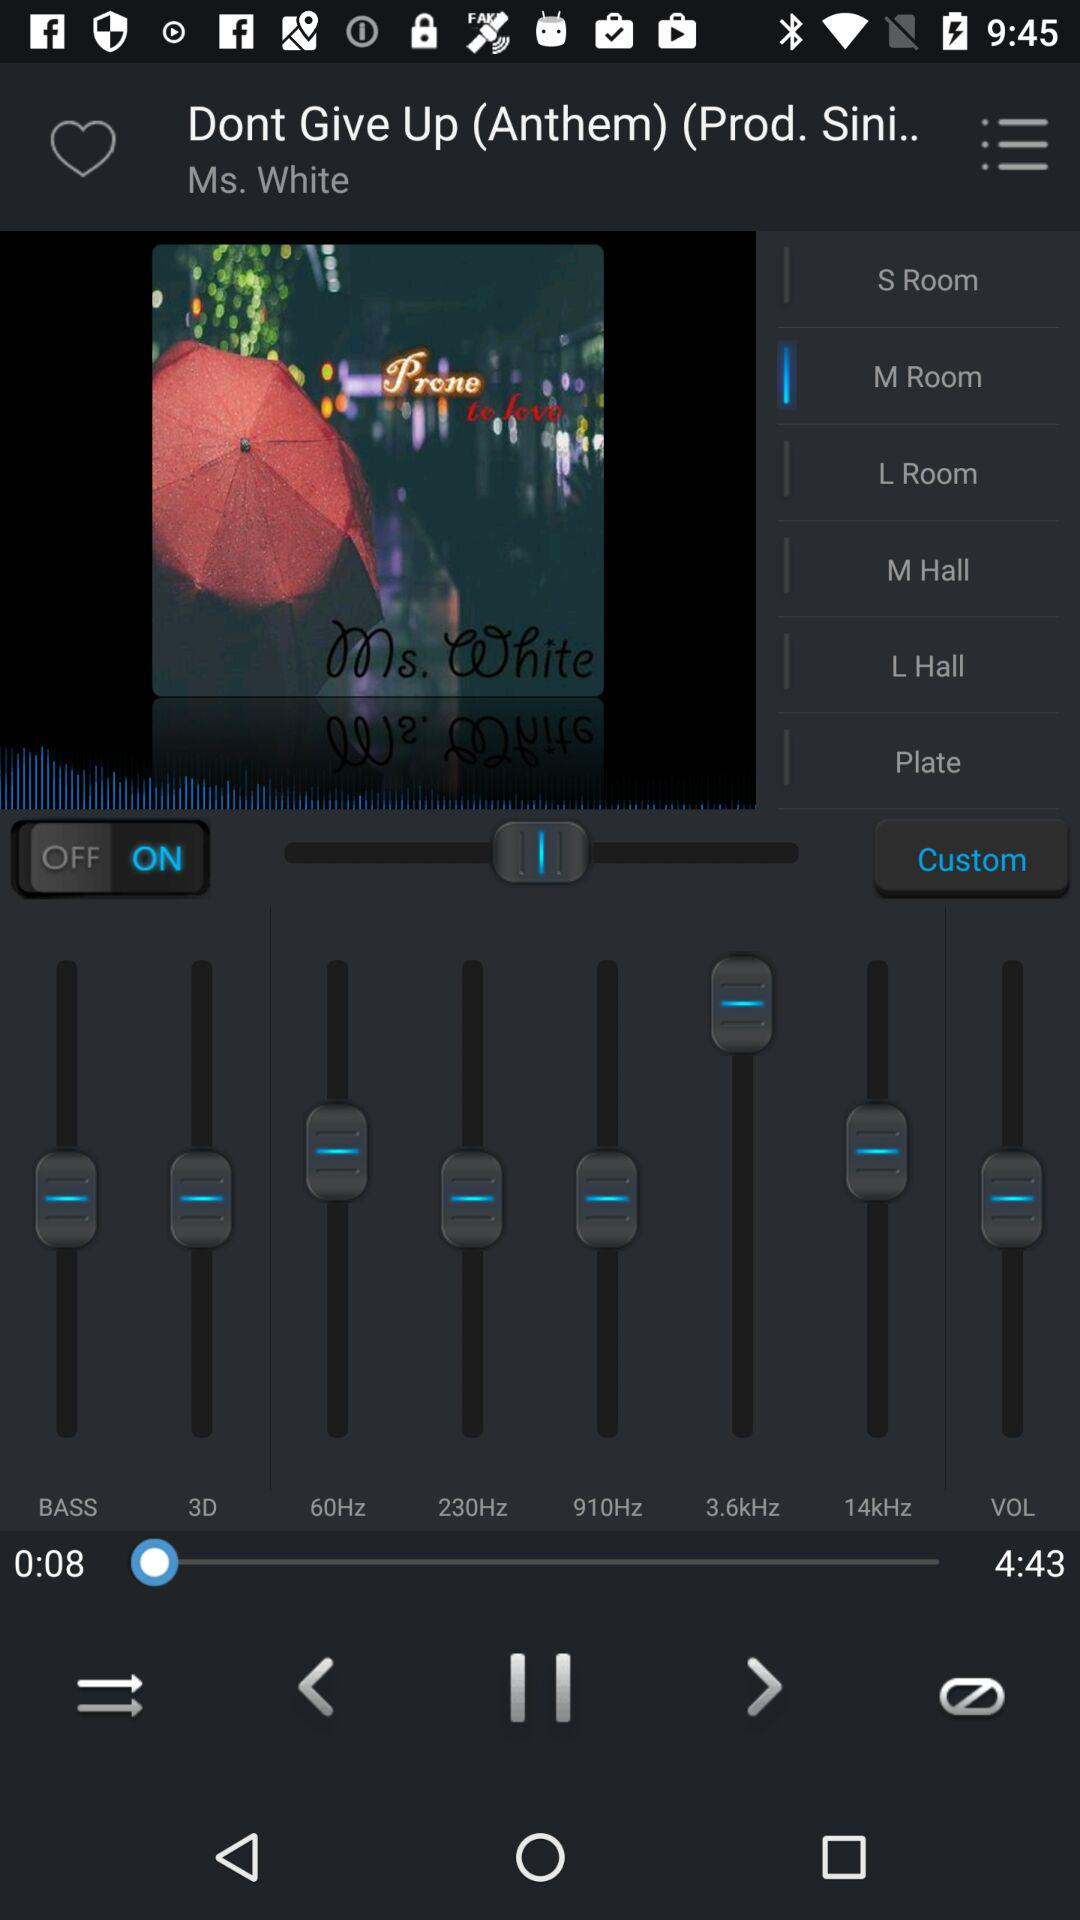What is the status of the custom? The status is "on". 